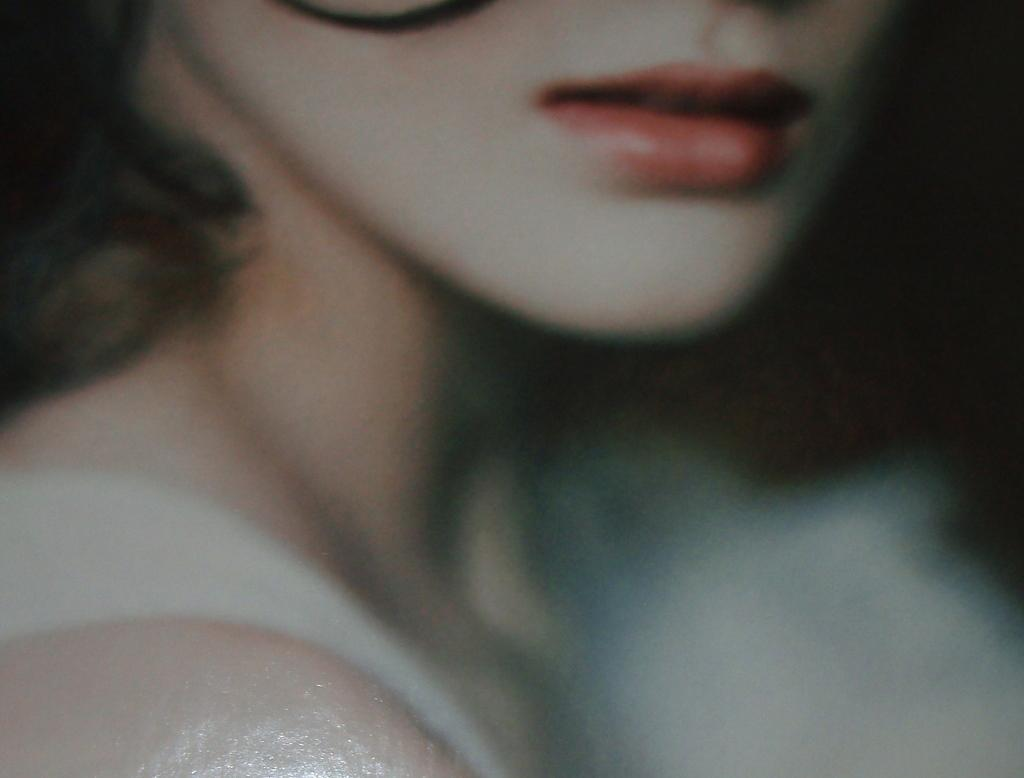What is the main subject of the image? The main subject of the image is a woman. What type of fear does the woman have in the image? There is no indication in the image of the woman having any fear. What type of bulb is visible in the image? There is no bulb present in the image. What type of wind can be seen blowing in the image? There is no wind present in the image. 